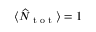<formula> <loc_0><loc_0><loc_500><loc_500>\langle \widehat { N } _ { t o t } \rangle = 1</formula> 